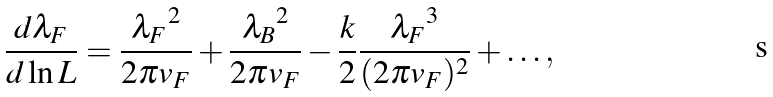Convert formula to latex. <formula><loc_0><loc_0><loc_500><loc_500>\frac { d \lambda _ { F } } { d \ln L } = \frac { { \lambda _ { F } } ^ { 2 } } { 2 \pi v _ { F } } + \frac { { \lambda _ { B } } ^ { 2 } } { 2 \pi v _ { F } } - \frac { k } { 2 } \frac { { \lambda _ { F } } ^ { 3 } } { ( 2 \pi v _ { F } ) ^ { 2 } } + \dots ,</formula> 